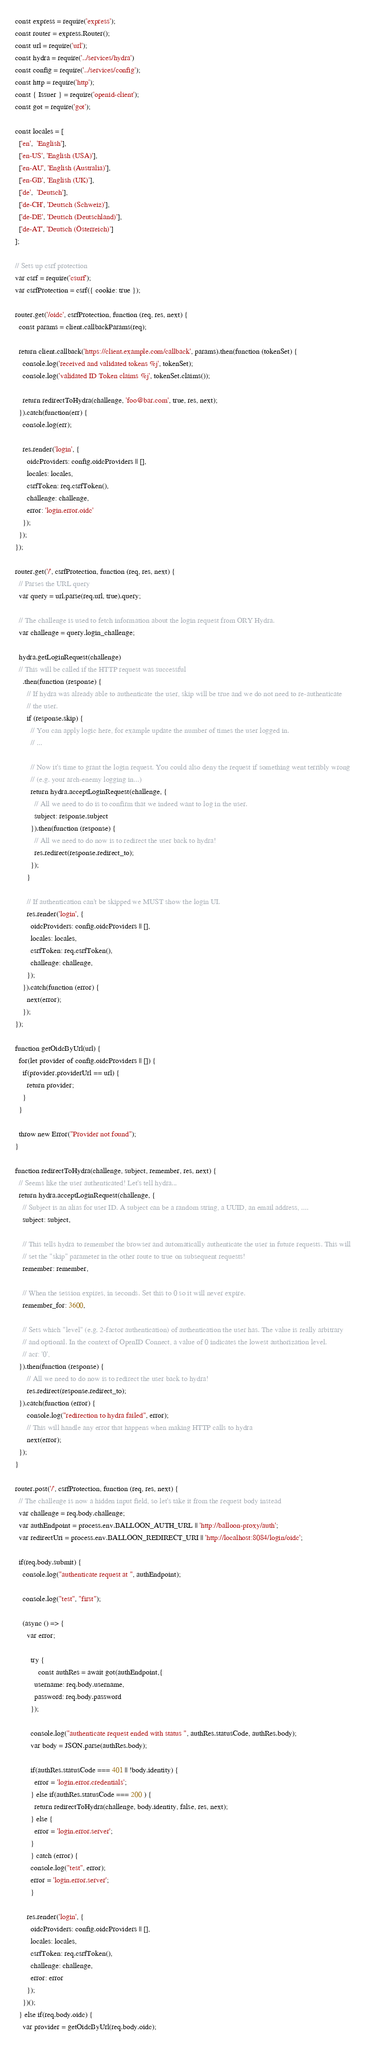<code> <loc_0><loc_0><loc_500><loc_500><_JavaScript_>const express = require('express');
const router = express.Router();
const url = require('url');
const hydra = require('../services/hydra')
const config = require('../services/config');
const http = require('http');
const { Issuer } = require('openid-client');
const got = require('got');

const locales = [
  ['en',  'English'],
  ['en-US', 'English (USA)'],
  ['en-AU', 'English (Australia)'],
  ['en-GB', 'English (UK)'],
  ['de',  'Deutsch'],
  ['de-CH', 'Deutsch (Schweiz)'],
  ['de-DE', 'Deutsch (Deutschland)'],
  ['de-AT', 'Deutsch (Österreich)']
];

// Sets up csrf protection
var csrf = require('csurf');
var csrfProtection = csrf({ cookie: true });

router.get('/oidc', csrfProtection, function (req, res, next) {
  const params = client.callbackParams(req);

  return client.callback('https://client.example.com/callback', params).then(function (tokenSet) {
    console.log('received and validated tokens %j', tokenSet);
    console.log('validated ID Token claims %j', tokenSet.claims());

    return redirectToHydra(challenge, 'foo@bar.com', true, res, next);
  }).catch(function(err) {
    console.log(err);

    res.render('login', {
      oidcProviders: config.oidcProviders || [],
      locales: locales,
      csrfToken: req.csrfToken(),
      challenge: challenge,
      error: 'login.error.oidc'
    });
  });
});

router.get('/', csrfProtection, function (req, res, next) {
  // Parses the URL query
  var query = url.parse(req.url, true).query;

  // The challenge is used to fetch information about the login request from ORY Hydra.
  var challenge = query.login_challenge;

  hydra.getLoginRequest(challenge)
  // This will be called if the HTTP request was successful
    .then(function (response) {
      // If hydra was already able to authenticate the user, skip will be true and we do not need to re-authenticate
      // the user.
      if (response.skip) {
        // You can apply logic here, for example update the number of times the user logged in.
        // ...

        // Now it's time to grant the login request. You could also deny the request if something went terribly wrong
        // (e.g. your arch-enemy logging in...)
        return hydra.acceptLoginRequest(challenge, {
          // All we need to do is to confirm that we indeed want to log in the user.
          subject: response.subject
        }).then(function (response) {
          // All we need to do now is to redirect the user back to hydra!
          res.redirect(response.redirect_to);
        });
      }

      // If authentication can't be skipped we MUST show the login UI.
      res.render('login', {
        oidcProviders: config.oidcProviders || [],
        locales: locales,
        csrfToken: req.csrfToken(),
        challenge: challenge,
      });
    }).catch(function (error) {
      next(error);
    });
});

function getOidcByUrl(url) {
  for(let provider of config.oidcProviders || []) {
    if(provider.providerUrl == url) {
      return provider;
    }
  }

  throw new Error("Provider not found");
}

function redirectToHydra(challenge, subject, remember, res, next) {
  // Seems like the user authenticated! Let's tell hydra...
  return hydra.acceptLoginRequest(challenge, {
    // Subject is an alias for user ID. A subject can be a random string, a UUID, an email address, ....
    subject: subject,

    // This tells hydra to remember the browser and automatically authenticate the user in future requests. This will
    // set the "skip" parameter in the other route to true on subsequent requests!
    remember: remember,

    // When the session expires, in seconds. Set this to 0 so it will never expire.
    remember_for: 3600,

    // Sets which "level" (e.g. 2-factor authentication) of authentication the user has. The value is really arbitrary
    // and optional. In the context of OpenID Connect, a value of 0 indicates the lowest authorization level.
    // acr: '0',
  }).then(function (response) {
      // All we need to do now is to redirect the user back to hydra!
      res.redirect(response.redirect_to);
  }).catch(function (error) {
      console.log("redirection to hydra failed", error);
      // This will handle any error that happens when making HTTP calls to hydra
      next(error);
  });
}

router.post('/', csrfProtection, function (req, res, next) {
  // The challenge is now a hidden input field, so let's take it from the request body instead
  var challenge = req.body.challenge;
  var authEndpoint = process.env.BALLOON_AUTH_URL || 'http://balloon-proxy/auth';
  var redirectUri = process.env.BALLOON_REDIRECT_URI || 'http://localhost:8084/login/oidc';

  if(req.body.submit) {
    console.log("authenticate request at ", authEndpoint);

    console.log("test", "first");

    (async () => {
      var error;

    	try {
    		const authRes = await got(authEndpoint,{
          username: req.body.username,
          password: req.body.password
        });

        console.log("authenticate request ended with status ", authRes.statusCode, authRes.body);
        var body = JSON.parse(authRes.body);

        if(authRes.statusCode === 401 || !body.identity) {
          error = 'login.error.credentials';
        } else if(authRes.statusCode === 200 ) {
          return redirectToHydra(challenge, body.identity, false, res, next);
        } else {
          error = 'login.error.server';
        }
    	} catch (error) {
        console.log("test", error);
        error = 'login.error.server';
    	}

      res.render('login', {
        oidcProviders: config.oidcProviders || [],
        locales: locales,
        csrfToken: req.csrfToken(),
        challenge: challenge,
        error: error
      });
    })();
  } else if(req.body.oidc) {
    var provider = getOidcByUrl(req.body.oidc);
</code> 